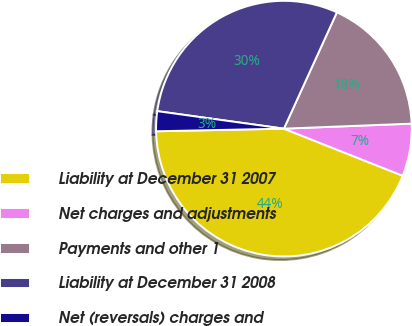<chart> <loc_0><loc_0><loc_500><loc_500><pie_chart><fcel>Liability at December 31 2007<fcel>Net charges and adjustments<fcel>Payments and other 1<fcel>Liability at December 31 2008<fcel>Net (reversals) charges and<nl><fcel>43.67%<fcel>6.63%<fcel>17.57%<fcel>29.62%<fcel>2.51%<nl></chart> 